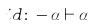<formula> <loc_0><loc_0><loc_500><loc_500>{ i d \colon - \alpha \vdash \alpha }</formula> 